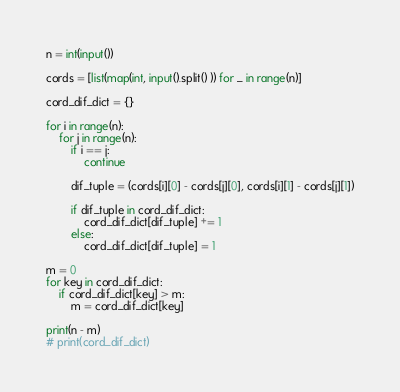<code> <loc_0><loc_0><loc_500><loc_500><_Python_>n = int(input())

cords = [list(map(int, input().split() )) for _ in range(n)]

cord_dif_dict = {}

for i in range(n):
	for j in range(n):
		if i == j:
			continue

		dif_tuple = (cords[i][0] - cords[j][0], cords[i][1] - cords[j][1])

		if dif_tuple in cord_dif_dict:
			cord_dif_dict[dif_tuple] += 1
		else:
			cord_dif_dict[dif_tuple] = 1

m = 0
for key in cord_dif_dict:
	if cord_dif_dict[key] > m:
		m = cord_dif_dict[key]

print(n - m)
# print(cord_dif_dict)</code> 